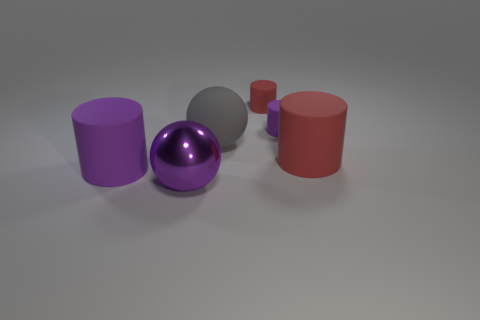Is the color of the large metal object the same as the tiny object that is in front of the small red thing?
Offer a very short reply. Yes. What is the color of the ball that is the same size as the gray thing?
Your response must be concise. Purple. Are there any other matte objects of the same shape as the large gray matte thing?
Give a very brief answer. No. Is the number of red matte objects less than the number of tiny purple matte objects?
Provide a short and direct response. No. There is a big thing right of the gray matte thing; what is its color?
Provide a succinct answer. Red. There is a purple object in front of the purple rubber object that is in front of the small purple object; what is its shape?
Your answer should be compact. Sphere. Is the material of the tiny red thing the same as the purple cylinder that is on the right side of the purple shiny object?
Your response must be concise. Yes. What is the shape of the tiny thing that is the same color as the large metallic sphere?
Provide a succinct answer. Cylinder. How many rubber cylinders are the same size as the gray rubber object?
Offer a very short reply. 2. Is the number of matte spheres to the left of the purple sphere less than the number of rubber cylinders?
Your answer should be compact. Yes. 